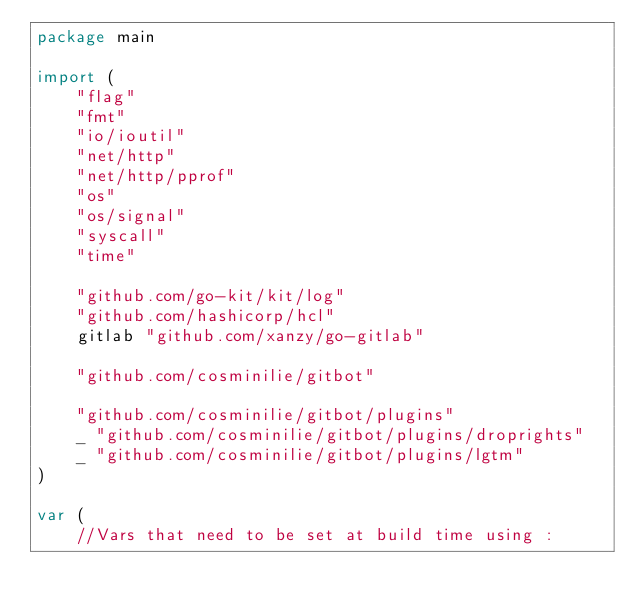Convert code to text. <code><loc_0><loc_0><loc_500><loc_500><_Go_>package main

import (
	"flag"
	"fmt"
	"io/ioutil"
	"net/http"
	"net/http/pprof"
	"os"
	"os/signal"
	"syscall"
	"time"

	"github.com/go-kit/kit/log"
	"github.com/hashicorp/hcl"
	gitlab "github.com/xanzy/go-gitlab"

	"github.com/cosminilie/gitbot"

	"github.com/cosminilie/gitbot/plugins"
	_ "github.com/cosminilie/gitbot/plugins/droprights"
	_ "github.com/cosminilie/gitbot/plugins/lgtm"
)

var (
	//Vars that need to be set at build time using :</code> 